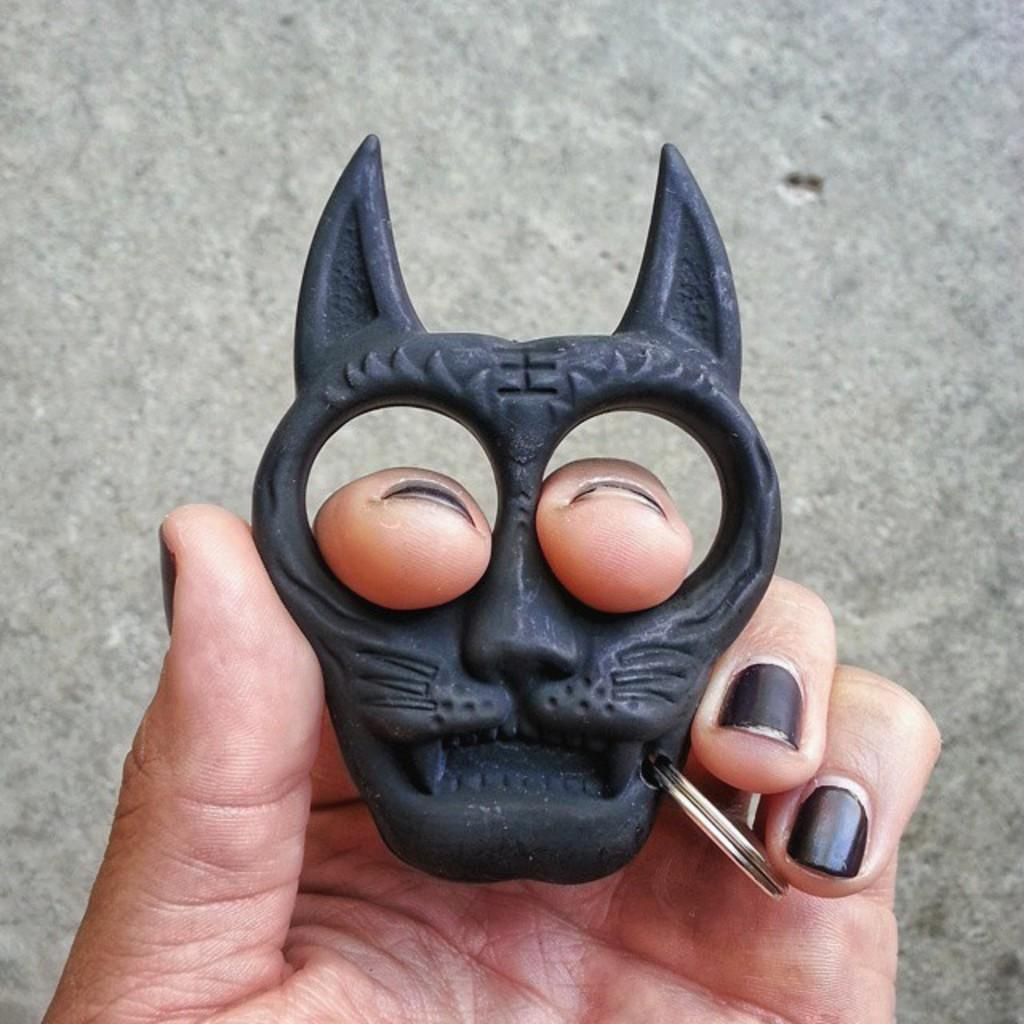What object is being held by a person in the image? There is a keychain in the image, and it is being held by a person. How many planes are visible in the image? There are no planes visible in the image; it only features a keychain being held by a person. What type of company is associated with the keychain in the image? There is no information about a company associated with the keychain in the image. 